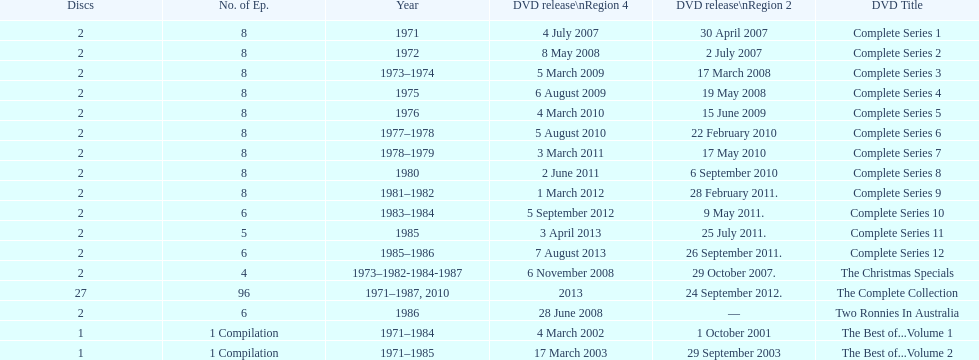True or false. the television show "the two ronnies" featured more than 10 episodes in a season. False. 